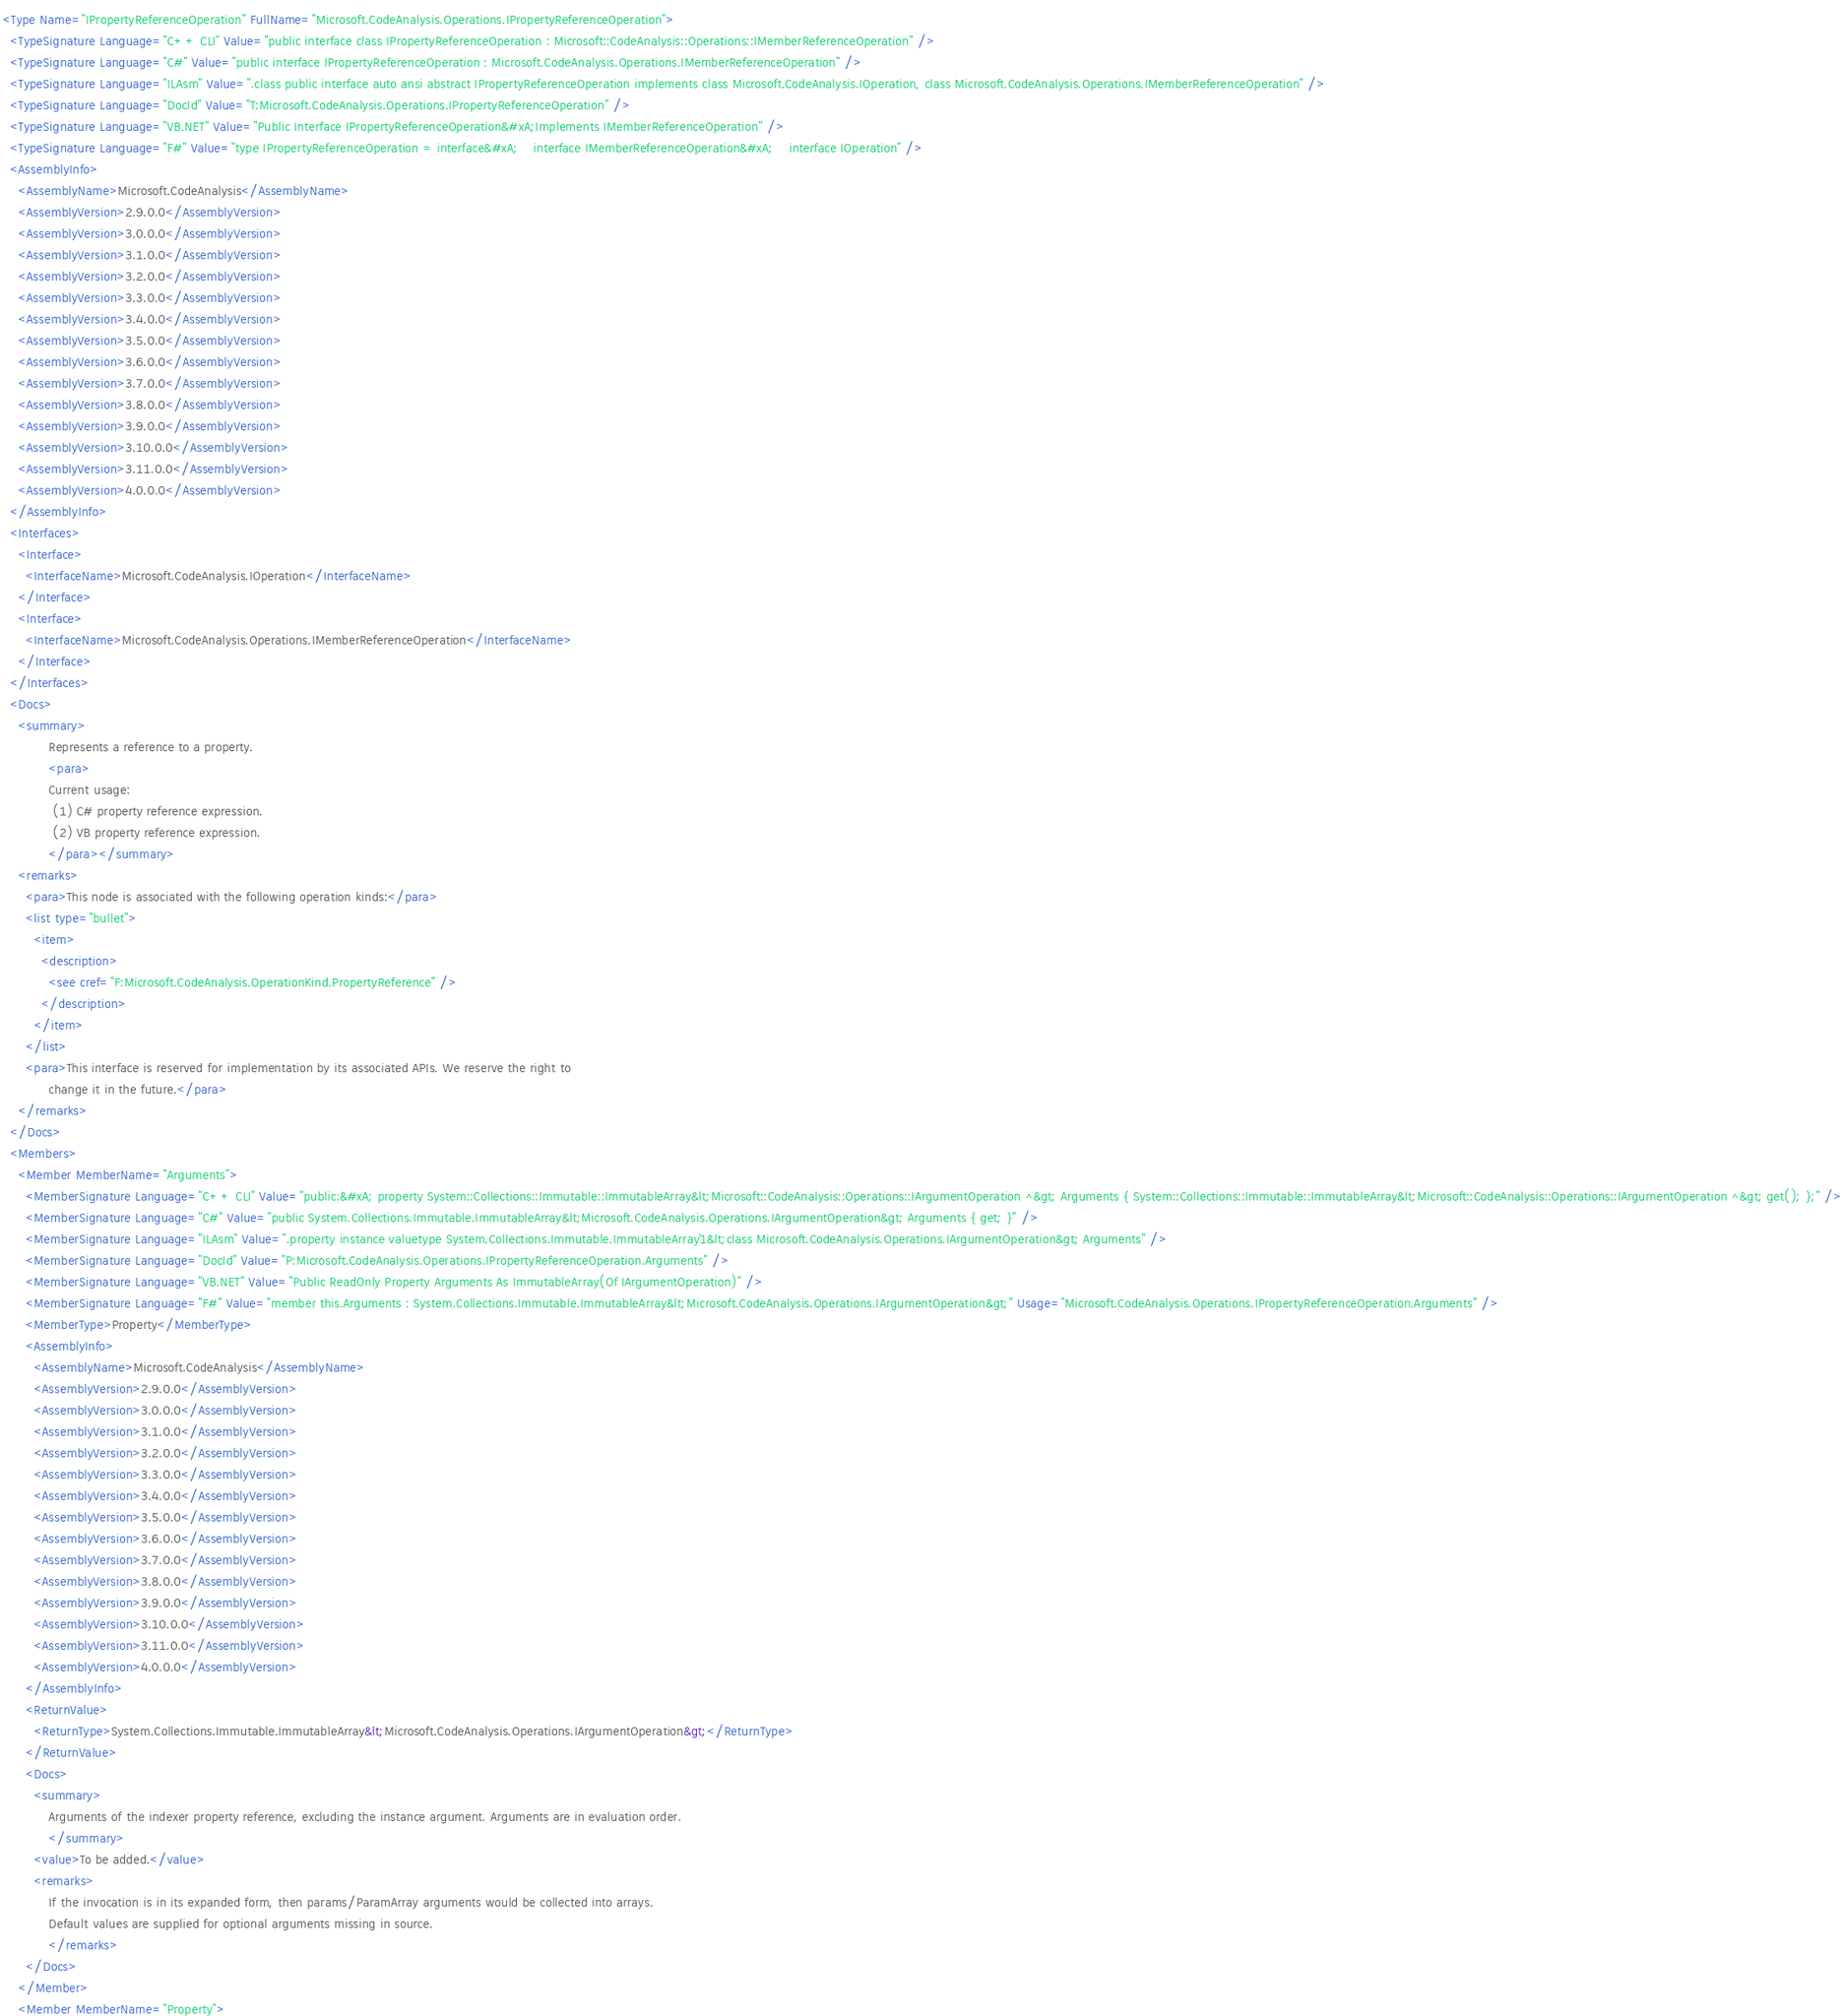<code> <loc_0><loc_0><loc_500><loc_500><_XML_><Type Name="IPropertyReferenceOperation" FullName="Microsoft.CodeAnalysis.Operations.IPropertyReferenceOperation">
  <TypeSignature Language="C++ CLI" Value="public interface class IPropertyReferenceOperation : Microsoft::CodeAnalysis::Operations::IMemberReferenceOperation" />
  <TypeSignature Language="C#" Value="public interface IPropertyReferenceOperation : Microsoft.CodeAnalysis.Operations.IMemberReferenceOperation" />
  <TypeSignature Language="ILAsm" Value=".class public interface auto ansi abstract IPropertyReferenceOperation implements class Microsoft.CodeAnalysis.IOperation, class Microsoft.CodeAnalysis.Operations.IMemberReferenceOperation" />
  <TypeSignature Language="DocId" Value="T:Microsoft.CodeAnalysis.Operations.IPropertyReferenceOperation" />
  <TypeSignature Language="VB.NET" Value="Public Interface IPropertyReferenceOperation&#xA;Implements IMemberReferenceOperation" />
  <TypeSignature Language="F#" Value="type IPropertyReferenceOperation = interface&#xA;    interface IMemberReferenceOperation&#xA;    interface IOperation" />
  <AssemblyInfo>
    <AssemblyName>Microsoft.CodeAnalysis</AssemblyName>
    <AssemblyVersion>2.9.0.0</AssemblyVersion>
    <AssemblyVersion>3.0.0.0</AssemblyVersion>
    <AssemblyVersion>3.1.0.0</AssemblyVersion>
    <AssemblyVersion>3.2.0.0</AssemblyVersion>
    <AssemblyVersion>3.3.0.0</AssemblyVersion>
    <AssemblyVersion>3.4.0.0</AssemblyVersion>
    <AssemblyVersion>3.5.0.0</AssemblyVersion>
    <AssemblyVersion>3.6.0.0</AssemblyVersion>
    <AssemblyVersion>3.7.0.0</AssemblyVersion>
    <AssemblyVersion>3.8.0.0</AssemblyVersion>
    <AssemblyVersion>3.9.0.0</AssemblyVersion>
    <AssemblyVersion>3.10.0.0</AssemblyVersion>
    <AssemblyVersion>3.11.0.0</AssemblyVersion>
    <AssemblyVersion>4.0.0.0</AssemblyVersion>
  </AssemblyInfo>
  <Interfaces>
    <Interface>
      <InterfaceName>Microsoft.CodeAnalysis.IOperation</InterfaceName>
    </Interface>
    <Interface>
      <InterfaceName>Microsoft.CodeAnalysis.Operations.IMemberReferenceOperation</InterfaceName>
    </Interface>
  </Interfaces>
  <Docs>
    <summary>
            Represents a reference to a property.
            <para>
            Current usage:
             (1) C# property reference expression.
             (2) VB property reference expression.
            </para></summary>
    <remarks>
      <para>This node is associated with the following operation kinds:</para>
      <list type="bullet">
        <item>
          <description>
            <see cref="F:Microsoft.CodeAnalysis.OperationKind.PropertyReference" />
          </description>
        </item>
      </list>
      <para>This interface is reserved for implementation by its associated APIs. We reserve the right to
            change it in the future.</para>
    </remarks>
  </Docs>
  <Members>
    <Member MemberName="Arguments">
      <MemberSignature Language="C++ CLI" Value="public:&#xA; property System::Collections::Immutable::ImmutableArray&lt;Microsoft::CodeAnalysis::Operations::IArgumentOperation ^&gt; Arguments { System::Collections::Immutable::ImmutableArray&lt;Microsoft::CodeAnalysis::Operations::IArgumentOperation ^&gt; get(); };" />
      <MemberSignature Language="C#" Value="public System.Collections.Immutable.ImmutableArray&lt;Microsoft.CodeAnalysis.Operations.IArgumentOperation&gt; Arguments { get; }" />
      <MemberSignature Language="ILAsm" Value=".property instance valuetype System.Collections.Immutable.ImmutableArray`1&lt;class Microsoft.CodeAnalysis.Operations.IArgumentOperation&gt; Arguments" />
      <MemberSignature Language="DocId" Value="P:Microsoft.CodeAnalysis.Operations.IPropertyReferenceOperation.Arguments" />
      <MemberSignature Language="VB.NET" Value="Public ReadOnly Property Arguments As ImmutableArray(Of IArgumentOperation)" />
      <MemberSignature Language="F#" Value="member this.Arguments : System.Collections.Immutable.ImmutableArray&lt;Microsoft.CodeAnalysis.Operations.IArgumentOperation&gt;" Usage="Microsoft.CodeAnalysis.Operations.IPropertyReferenceOperation.Arguments" />
      <MemberType>Property</MemberType>
      <AssemblyInfo>
        <AssemblyName>Microsoft.CodeAnalysis</AssemblyName>
        <AssemblyVersion>2.9.0.0</AssemblyVersion>
        <AssemblyVersion>3.0.0.0</AssemblyVersion>
        <AssemblyVersion>3.1.0.0</AssemblyVersion>
        <AssemblyVersion>3.2.0.0</AssemblyVersion>
        <AssemblyVersion>3.3.0.0</AssemblyVersion>
        <AssemblyVersion>3.4.0.0</AssemblyVersion>
        <AssemblyVersion>3.5.0.0</AssemblyVersion>
        <AssemblyVersion>3.6.0.0</AssemblyVersion>
        <AssemblyVersion>3.7.0.0</AssemblyVersion>
        <AssemblyVersion>3.8.0.0</AssemblyVersion>
        <AssemblyVersion>3.9.0.0</AssemblyVersion>
        <AssemblyVersion>3.10.0.0</AssemblyVersion>
        <AssemblyVersion>3.11.0.0</AssemblyVersion>
        <AssemblyVersion>4.0.0.0</AssemblyVersion>
      </AssemblyInfo>
      <ReturnValue>
        <ReturnType>System.Collections.Immutable.ImmutableArray&lt;Microsoft.CodeAnalysis.Operations.IArgumentOperation&gt;</ReturnType>
      </ReturnValue>
      <Docs>
        <summary>
            Arguments of the indexer property reference, excluding the instance argument. Arguments are in evaluation order.
            </summary>
        <value>To be added.</value>
        <remarks>
            If the invocation is in its expanded form, then params/ParamArray arguments would be collected into arrays.
            Default values are supplied for optional arguments missing in source.
            </remarks>
      </Docs>
    </Member>
    <Member MemberName="Property"></code> 